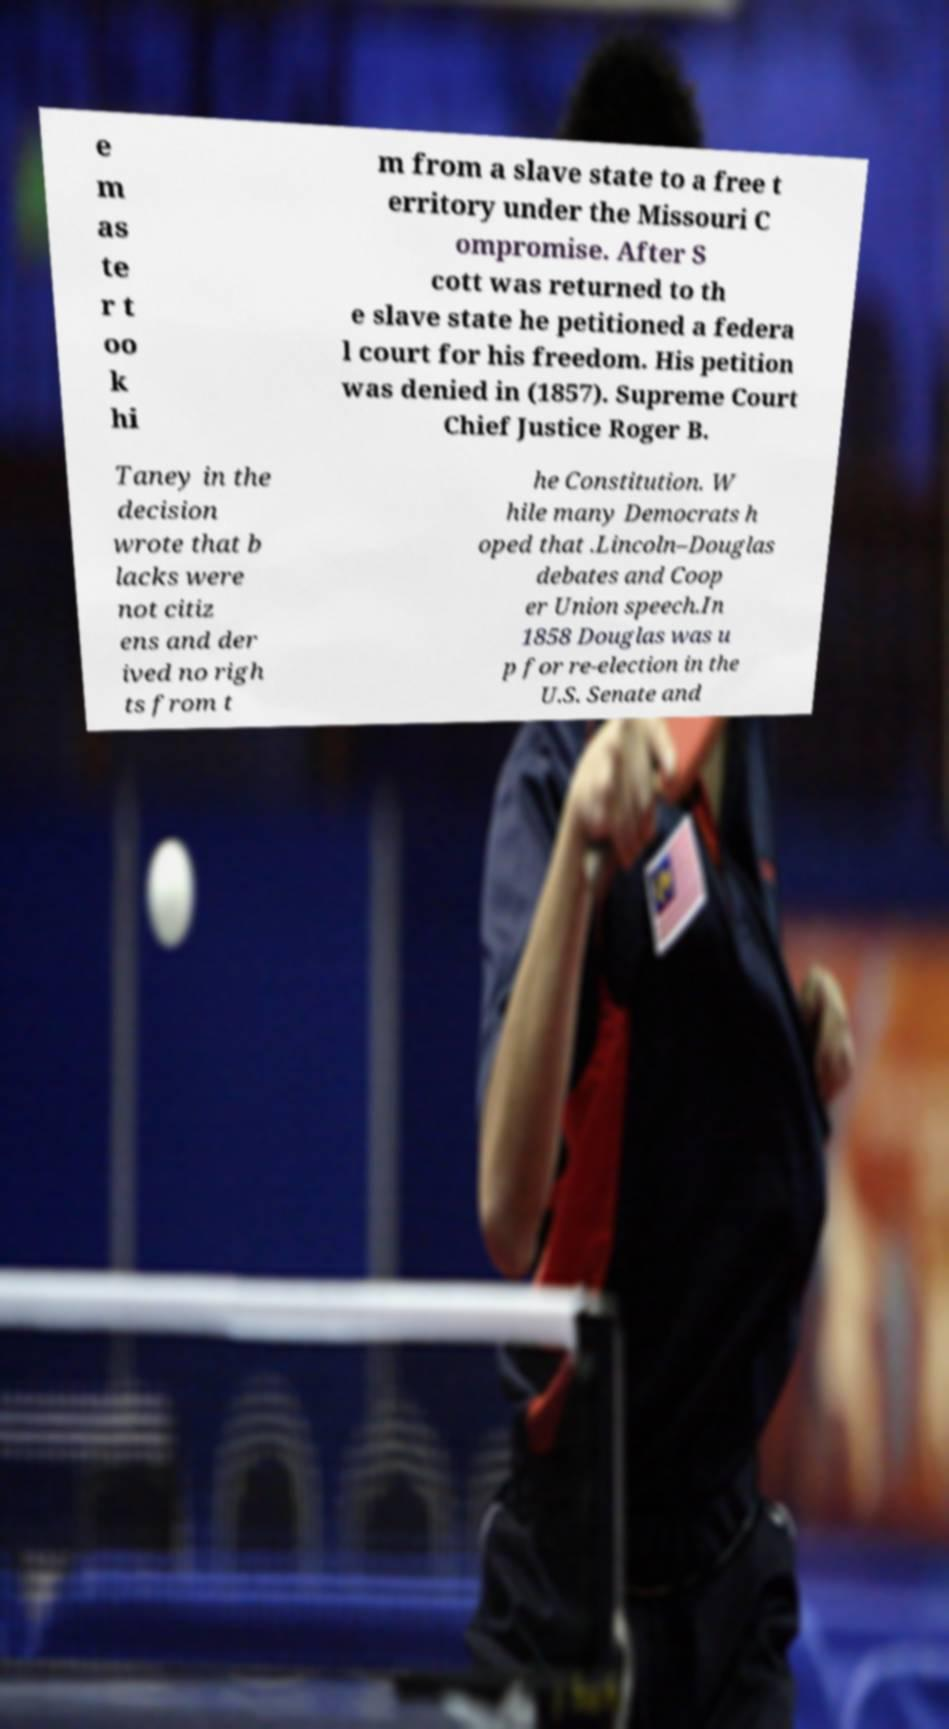Can you accurately transcribe the text from the provided image for me? e m as te r t oo k hi m from a slave state to a free t erritory under the Missouri C ompromise. After S cott was returned to th e slave state he petitioned a federa l court for his freedom. His petition was denied in (1857). Supreme Court Chief Justice Roger B. Taney in the decision wrote that b lacks were not citiz ens and der ived no righ ts from t he Constitution. W hile many Democrats h oped that .Lincoln–Douglas debates and Coop er Union speech.In 1858 Douglas was u p for re-election in the U.S. Senate and 